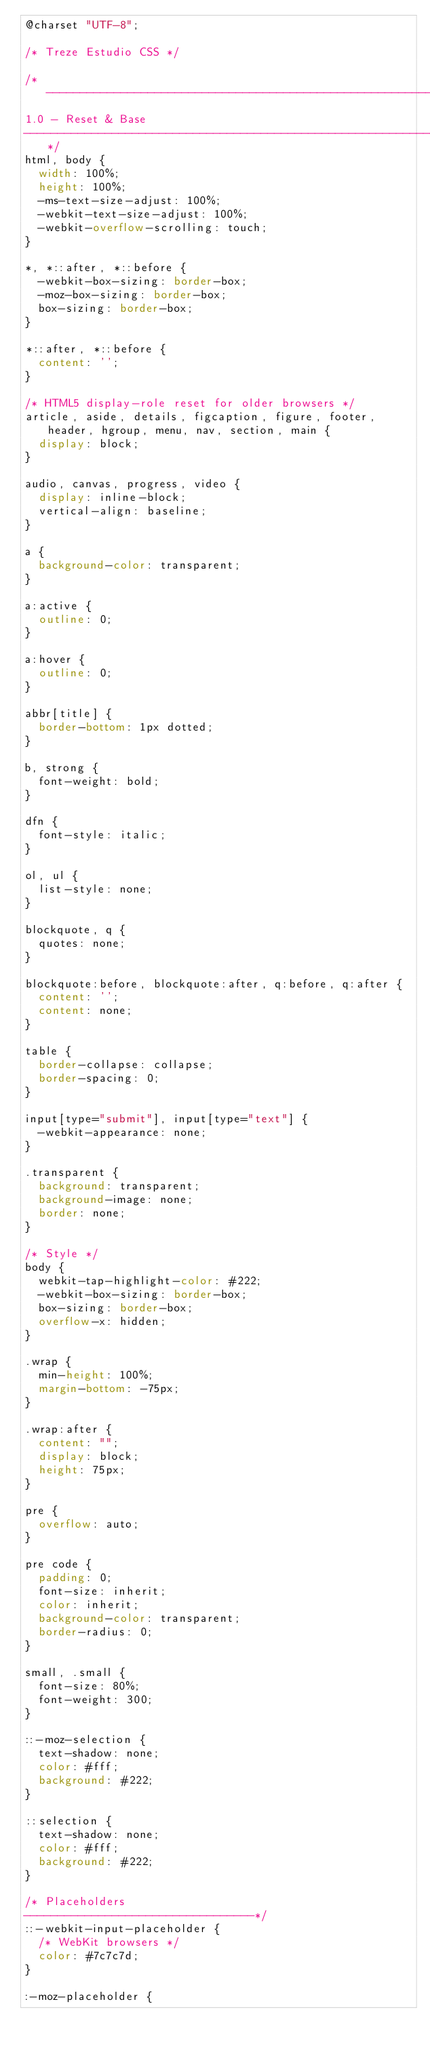<code> <loc_0><loc_0><loc_500><loc_500><_CSS_>@charset "UTF-8";

/* Treze Estudio CSS */

/*--------------------------------------------------------------
1.0 - Reset & Base
--------------------------------------------------------------*/
html, body {
	width: 100%;
	height: 100%;
	-ms-text-size-adjust: 100%;
	-webkit-text-size-adjust: 100%;
	-webkit-overflow-scrolling: touch;
}

*, *::after, *::before {
	-webkit-box-sizing: border-box;
	-moz-box-sizing: border-box;
	box-sizing: border-box;
}

*::after, *::before {
	content: '';
}

/* HTML5 display-role reset for older browsers */
article, aside, details, figcaption, figure, footer, header, hgroup, menu, nav, section, main {
	display: block;
}

audio, canvas, progress, video {
	display: inline-block;
	vertical-align: baseline;
}

a {
	background-color: transparent;
}

a:active {
	outline: 0;
}

a:hover {
	outline: 0;
}

abbr[title] {
	border-bottom: 1px dotted;
}

b, strong {
	font-weight: bold;
}

dfn {
	font-style: italic;
}

ol, ul {
	list-style: none;
}

blockquote, q {
	quotes: none;
}

blockquote:before, blockquote:after, q:before, q:after {
	content: '';
	content: none;
}

table {
	border-collapse: collapse;
	border-spacing: 0;
}

input[type="submit"], input[type="text"] {
	-webkit-appearance: none;
}

.transparent {
	background: transparent;
	background-image: none;
	border: none;
}

/* Style */
body {
	webkit-tap-highlight-color: #222;
	-webkit-box-sizing: border-box;
	box-sizing: border-box;
	overflow-x: hidden;
}

.wrap {
	min-height: 100%;
	margin-bottom: -75px;
}

.wrap:after {
	content: "";
	display: block;
	height: 75px;
}

pre {
	overflow: auto;
}

pre code {
	padding: 0;
	font-size: inherit;
	color: inherit;
	background-color: transparent;
	border-radius: 0;
}

small, .small {
	font-size: 80%;
	font-weight: 300;
}

::-moz-selection {
	text-shadow: none;
	color: #fff;
	background: #222;
}

::selection {
	text-shadow: none;
	color: #fff;
	background: #222;
}

/* Placeholders
----------------------------------*/
::-webkit-input-placeholder {
	/* WebKit browsers */
	color: #7c7c7d;
}

:-moz-placeholder {</code> 